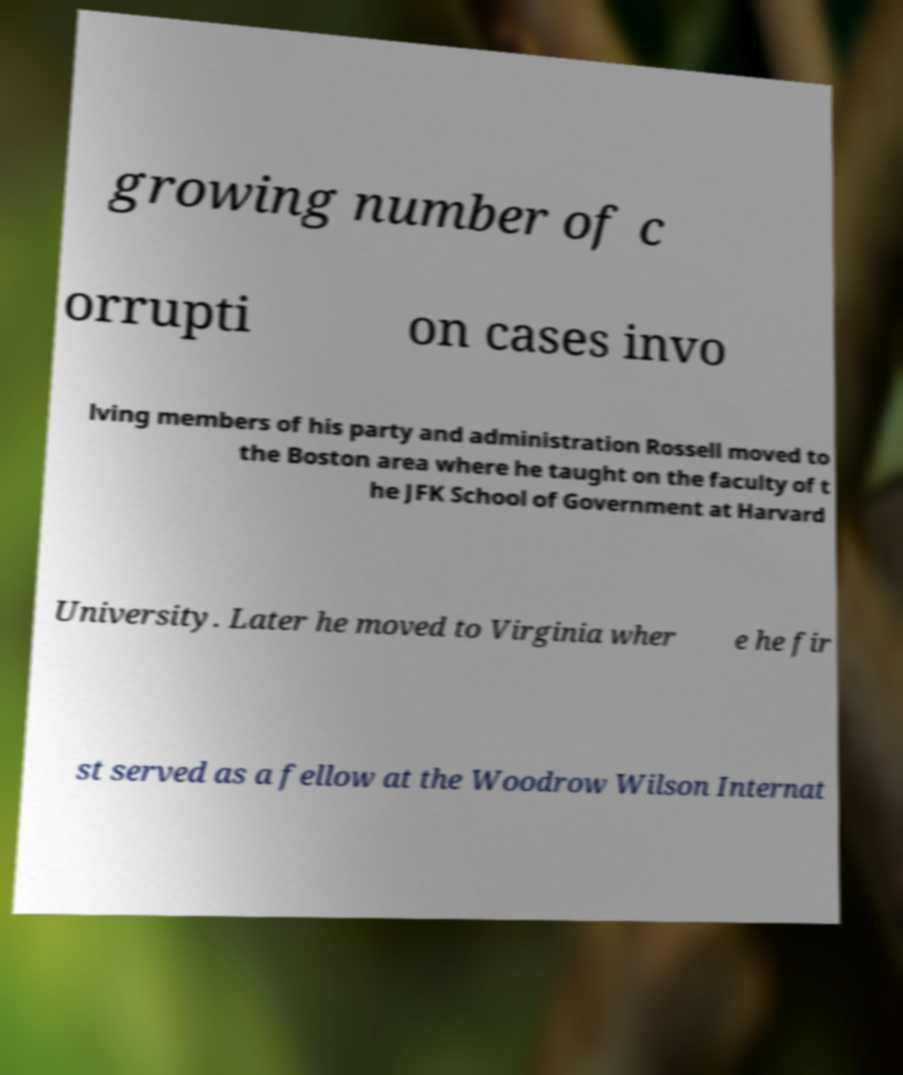Can you accurately transcribe the text from the provided image for me? growing number of c orrupti on cases invo lving members of his party and administration Rossell moved to the Boston area where he taught on the faculty of t he JFK School of Government at Harvard University. Later he moved to Virginia wher e he fir st served as a fellow at the Woodrow Wilson Internat 